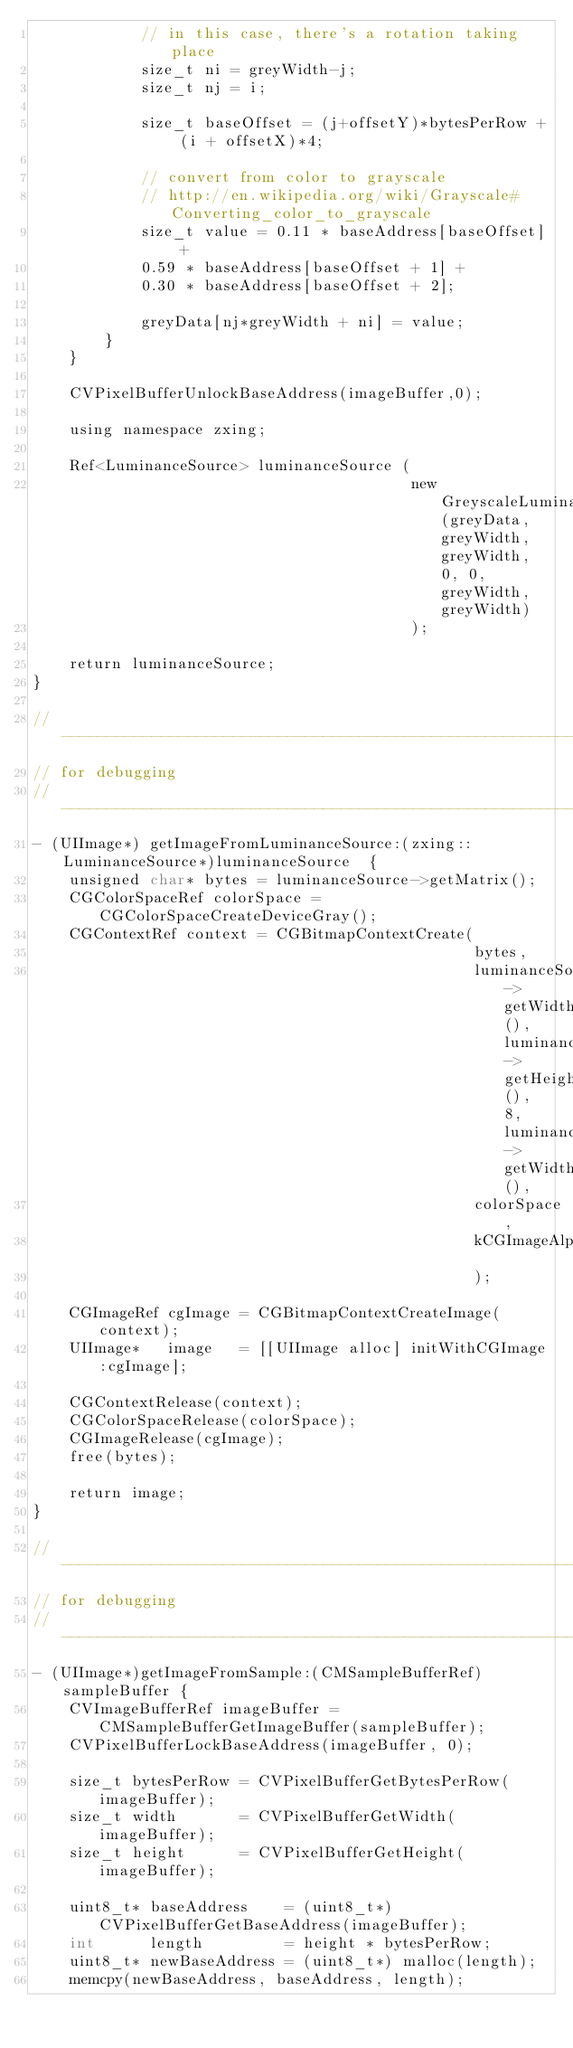<code> <loc_0><loc_0><loc_500><loc_500><_ObjectiveC_>            // in this case, there's a rotation taking place
            size_t ni = greyWidth-j;
            size_t nj = i;
            
            size_t baseOffset = (j+offsetY)*bytesPerRow + (i + offsetX)*4;
            
            // convert from color to grayscale
            // http://en.wikipedia.org/wiki/Grayscale#Converting_color_to_grayscale
            size_t value = 0.11 * baseAddress[baseOffset] +
            0.59 * baseAddress[baseOffset + 1] +
            0.30 * baseAddress[baseOffset + 2];
            
            greyData[nj*greyWidth + ni] = value;
        }
    }
    
    CVPixelBufferUnlockBaseAddress(imageBuffer,0);
    
    using namespace zxing;
    
    Ref<LuminanceSource> luminanceSource (
                                          new GreyscaleLuminanceSource(greyData, greyWidth, greyWidth, 0, 0, greyWidth, greyWidth)
                                          );
    
    return luminanceSource;
}

//--------------------------------------------------------------------------
// for debugging
//--------------------------------------------------------------------------
- (UIImage*) getImageFromLuminanceSource:(zxing::LuminanceSource*)luminanceSource  {
    unsigned char* bytes = luminanceSource->getMatrix();
    CGColorSpaceRef colorSpace = CGColorSpaceCreateDeviceGray();
    CGContextRef context = CGBitmapContextCreate(
                                                 bytes,
                                                 luminanceSource->getWidth(), luminanceSource->getHeight(), 8, luminanceSource->getWidth(),
                                                 colorSpace,
                                                 kCGImageAlphaNone
                                                 );
    
    CGImageRef cgImage = CGBitmapContextCreateImage(context);
    UIImage*   image   = [[UIImage alloc] initWithCGImage:cgImage];
    
    CGContextRelease(context);
    CGColorSpaceRelease(colorSpace);
    CGImageRelease(cgImage);
    free(bytes);
    
    return image;
}

//--------------------------------------------------------------------------
// for debugging
//--------------------------------------------------------------------------
- (UIImage*)getImageFromSample:(CMSampleBufferRef)sampleBuffer {
    CVImageBufferRef imageBuffer = CMSampleBufferGetImageBuffer(sampleBuffer);
    CVPixelBufferLockBaseAddress(imageBuffer, 0);
    
    size_t bytesPerRow = CVPixelBufferGetBytesPerRow(imageBuffer);
    size_t width       = CVPixelBufferGetWidth(imageBuffer);
    size_t height      = CVPixelBufferGetHeight(imageBuffer);
    
    uint8_t* baseAddress    = (uint8_t*) CVPixelBufferGetBaseAddress(imageBuffer);
    int      length         = height * bytesPerRow;
    uint8_t* newBaseAddress = (uint8_t*) malloc(length);
    memcpy(newBaseAddress, baseAddress, length);</code> 